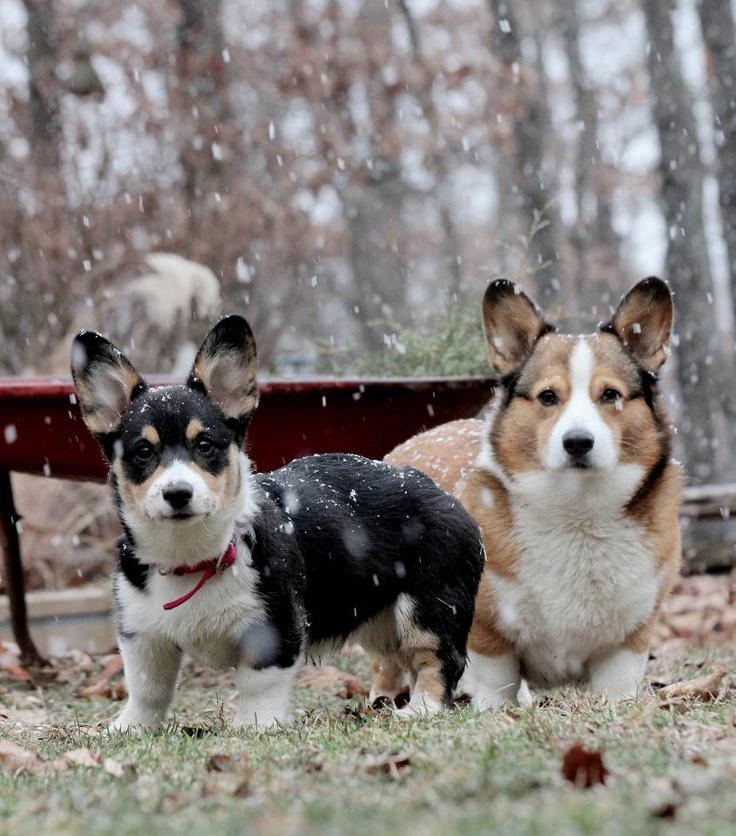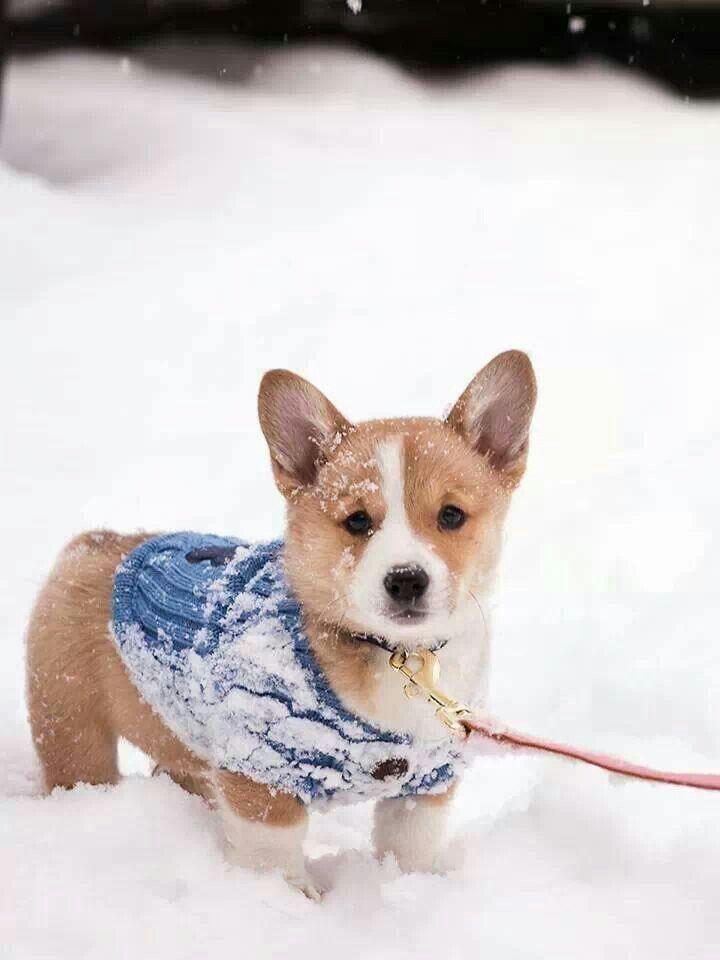The first image is the image on the left, the second image is the image on the right. Examine the images to the left and right. Is the description "There are exactly 3 dogs." accurate? Answer yes or no. Yes. The first image is the image on the left, the second image is the image on the right. For the images shown, is this caption "There are three dogs in the image pair." true? Answer yes or no. Yes. 